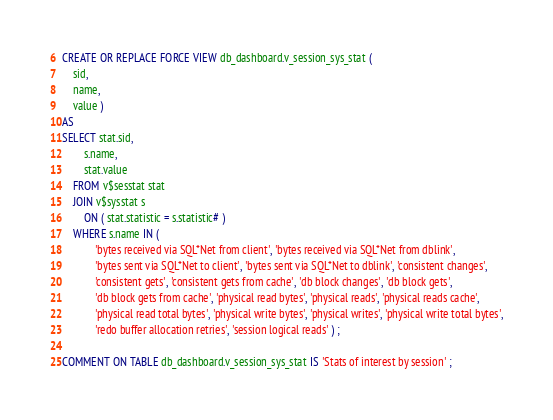<code> <loc_0><loc_0><loc_500><loc_500><_SQL_>CREATE OR REPLACE FORCE VIEW db_dashboard.v_session_sys_stat (
    sid,
    name,
    value )
AS
SELECT stat.sid,
        s.name,
        stat.value
    FROM v$sesstat stat
    JOIN v$sysstat s
        ON ( stat.statistic = s.statistic# )
    WHERE s.name IN (
            'bytes received via SQL*Net from client', 'bytes received via SQL*Net from dblink',
            'bytes sent via SQL*Net to client', 'bytes sent via SQL*Net to dblink', 'consistent changes',
            'consistent gets', 'consistent gets from cache', 'db block changes', 'db block gets',
            'db block gets from cache', 'physical read bytes', 'physical reads', 'physical reads cache',
            'physical read total bytes', 'physical write bytes', 'physical writes', 'physical write total bytes',
            'redo buffer allocation retries', 'session logical reads' ) ;

COMMENT ON TABLE db_dashboard.v_session_sys_stat IS 'Stats of interest by session' ;

</code> 